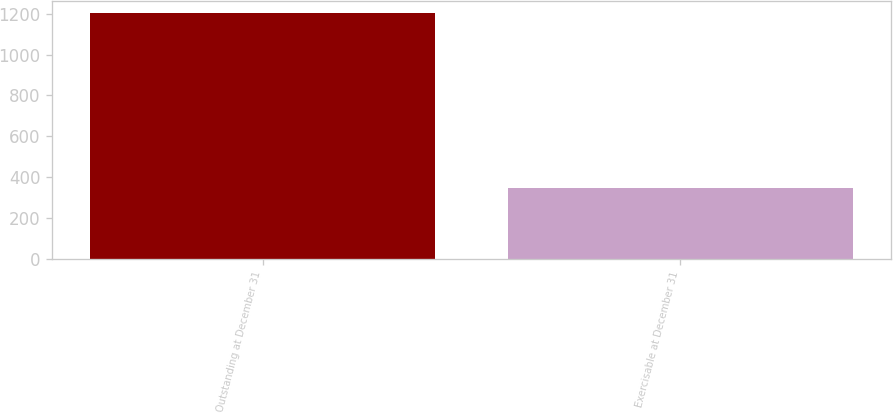Convert chart to OTSL. <chart><loc_0><loc_0><loc_500><loc_500><bar_chart><fcel>Outstanding at December 31<fcel>Exercisable at December 31<nl><fcel>1201<fcel>346<nl></chart> 